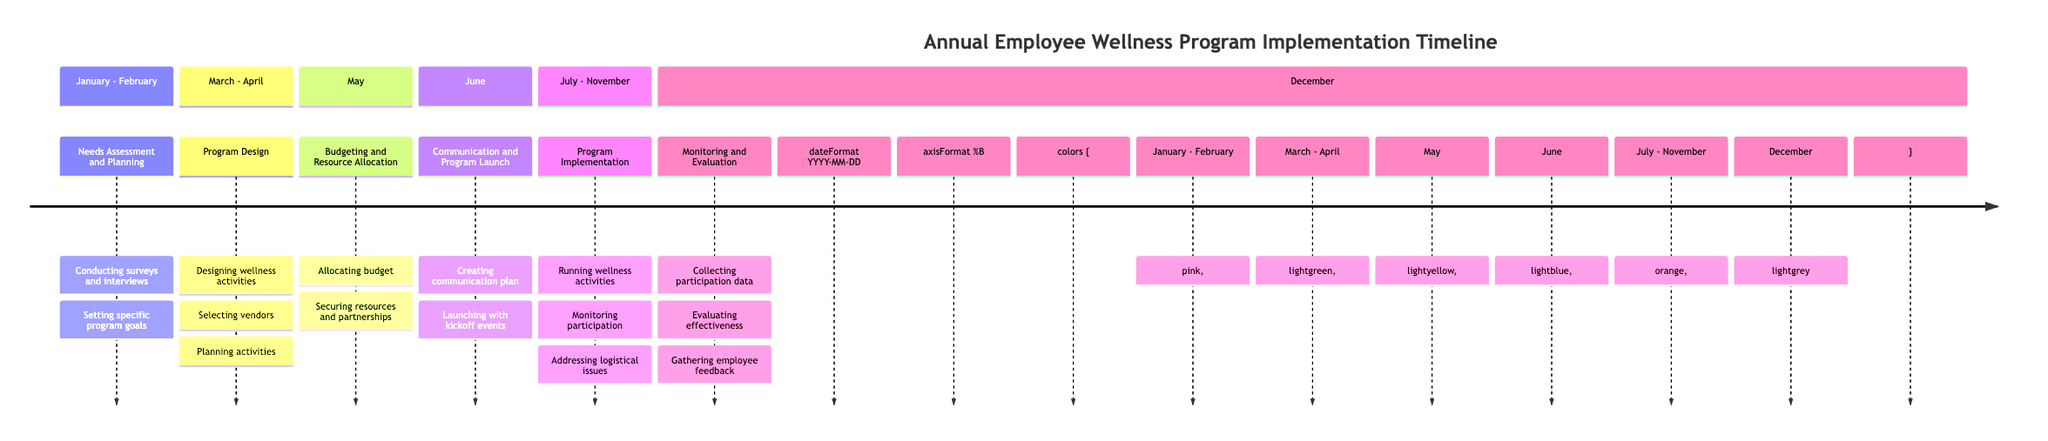What are the first two stages of the employee wellness program implementation? The first two stages listed in the diagram are "Needs Assessment and Planning" and "Program Design." They are located sequentially at the beginning of the timeline.
Answer: Needs Assessment and Planning, Program Design How long does the entire program implementation span? The implementation stages from "Program Implementation" take place from July to November, making the span of the entire implementation five months.
Answer: Five months In which month does the Budgeting and Resource Allocation stage occur? The diagram specifies that the "Budgeting and Resource Allocation" stage is scheduled for May, which is clearly marked in that section.
Answer: May What is the last stage of the implementation timeline? The last stage presented in the timeline is "Monitoring and Evaluation," which is detailed as occurring in December.
Answer: Monitoring and Evaluation How many stages are there in total for the employee wellness program implementation? By counting each individual stage listed in the diagram, there are a total of six distinct stages shown.
Answer: Six stages Which stage involves selecting vendors? The "Program Design" stage includes the task of selecting vendors as part of its description, indicating it happens during this stage from March to April.
Answer: Program Design What activities are planned during the Program Implementation stage? According to the description for the "Program Implementation" stage, the activities include running wellness activities, monitoring participation, and addressing logistical issues.
Answer: Running wellness activities, monitoring participation, addressing logistical issues What is the focus of the Needs Assessment and Planning stage? The primary focus of the "Needs Assessment and Planning" stage is to conduct surveys and interviews to identify employee health needs and preferences, and to set specific program goals.
Answer: Conduct surveys and interviews, set specific program goals In which section is the Communication and Program Launch scheduled? The "Communication and Program Launch" stage is scheduled for June, as indicated in the section of the diagram focused on that month.
Answer: June 